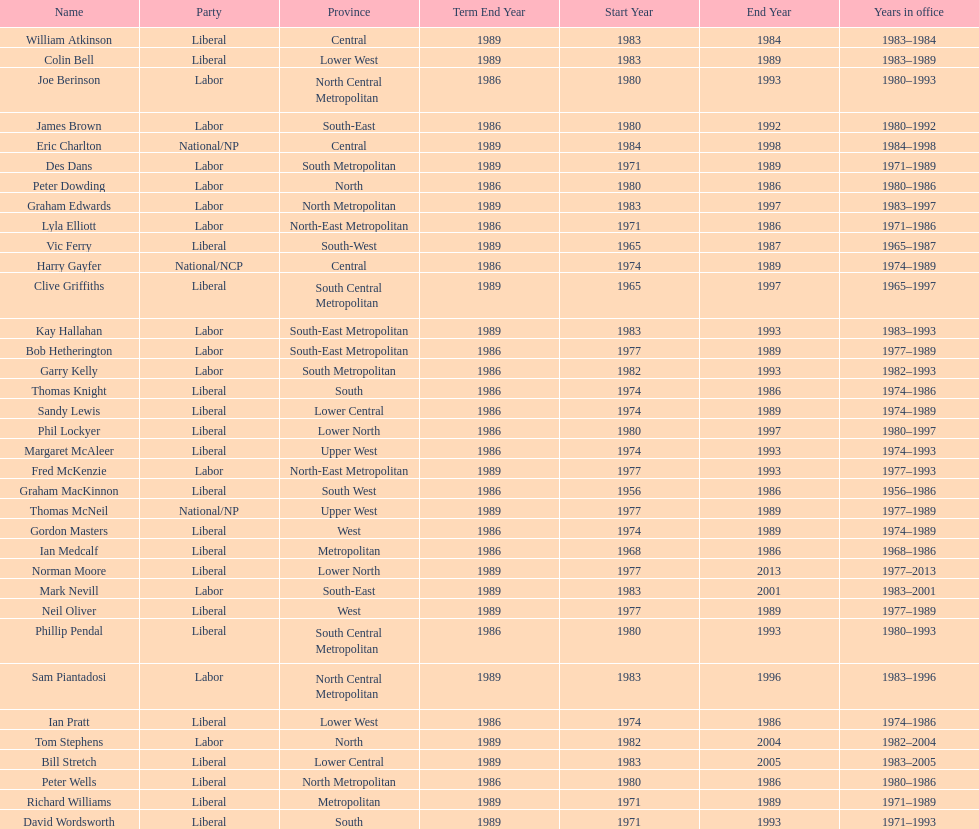What was phil lockyer's party? Liberal. 